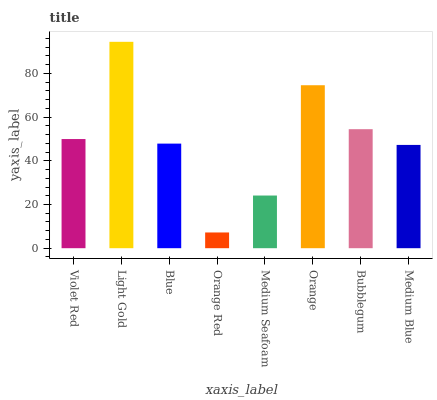Is Orange Red the minimum?
Answer yes or no. Yes. Is Light Gold the maximum?
Answer yes or no. Yes. Is Blue the minimum?
Answer yes or no. No. Is Blue the maximum?
Answer yes or no. No. Is Light Gold greater than Blue?
Answer yes or no. Yes. Is Blue less than Light Gold?
Answer yes or no. Yes. Is Blue greater than Light Gold?
Answer yes or no. No. Is Light Gold less than Blue?
Answer yes or no. No. Is Violet Red the high median?
Answer yes or no. Yes. Is Blue the low median?
Answer yes or no. Yes. Is Medium Blue the high median?
Answer yes or no. No. Is Bubblegum the low median?
Answer yes or no. No. 